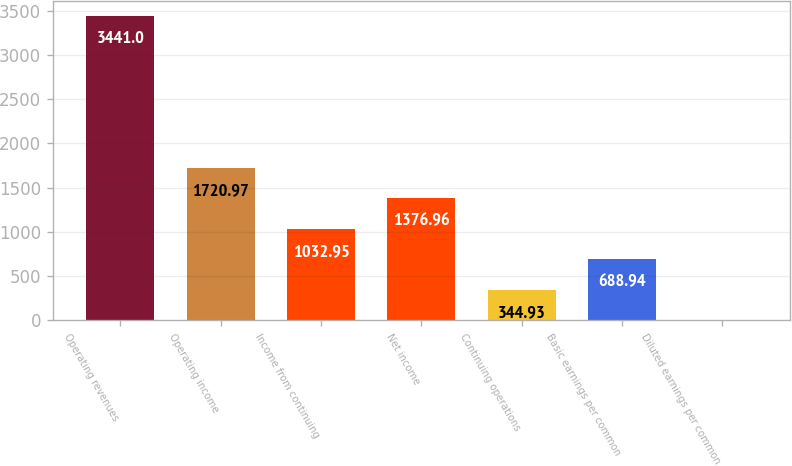Convert chart to OTSL. <chart><loc_0><loc_0><loc_500><loc_500><bar_chart><fcel>Operating revenues<fcel>Operating income<fcel>Income from continuing<fcel>Net income<fcel>Continuing operations<fcel>Basic earnings per common<fcel>Diluted earnings per common<nl><fcel>3441<fcel>1720.97<fcel>1032.95<fcel>1376.96<fcel>344.93<fcel>688.94<fcel>0.92<nl></chart> 